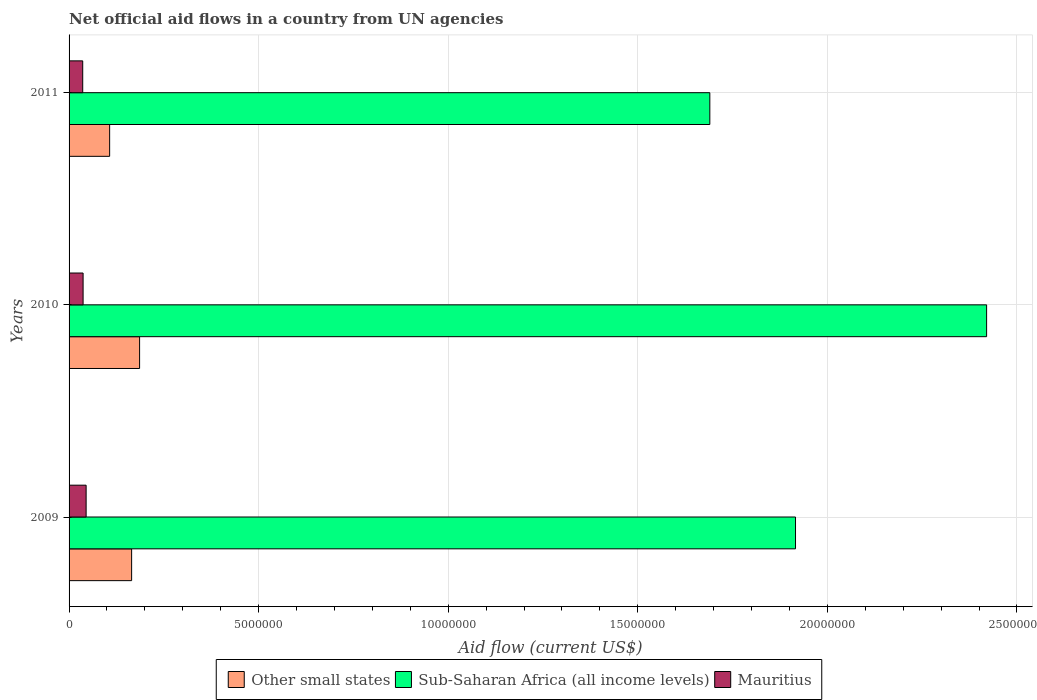How many different coloured bars are there?
Your response must be concise. 3. Are the number of bars on each tick of the Y-axis equal?
Keep it short and to the point. Yes. How many bars are there on the 3rd tick from the bottom?
Keep it short and to the point. 3. In how many cases, is the number of bars for a given year not equal to the number of legend labels?
Provide a short and direct response. 0. What is the net official aid flow in Other small states in 2009?
Provide a succinct answer. 1.65e+06. Across all years, what is the maximum net official aid flow in Mauritius?
Your answer should be very brief. 4.50e+05. Across all years, what is the minimum net official aid flow in Other small states?
Offer a terse response. 1.07e+06. In which year was the net official aid flow in Sub-Saharan Africa (all income levels) minimum?
Your answer should be compact. 2011. What is the total net official aid flow in Other small states in the graph?
Provide a short and direct response. 4.58e+06. What is the difference between the net official aid flow in Other small states in 2009 and that in 2011?
Make the answer very short. 5.80e+05. What is the difference between the net official aid flow in Sub-Saharan Africa (all income levels) in 2009 and the net official aid flow in Other small states in 2011?
Provide a short and direct response. 1.81e+07. What is the average net official aid flow in Mauritius per year?
Keep it short and to the point. 3.93e+05. In the year 2011, what is the difference between the net official aid flow in Sub-Saharan Africa (all income levels) and net official aid flow in Mauritius?
Your response must be concise. 1.65e+07. In how many years, is the net official aid flow in Sub-Saharan Africa (all income levels) greater than 13000000 US$?
Ensure brevity in your answer.  3. What is the ratio of the net official aid flow in Mauritius in 2010 to that in 2011?
Provide a succinct answer. 1.03. Is the net official aid flow in Other small states in 2009 less than that in 2010?
Offer a very short reply. Yes. What is the difference between the highest and the lowest net official aid flow in Sub-Saharan Africa (all income levels)?
Your response must be concise. 7.30e+06. In how many years, is the net official aid flow in Mauritius greater than the average net official aid flow in Mauritius taken over all years?
Offer a very short reply. 1. What does the 2nd bar from the top in 2011 represents?
Give a very brief answer. Sub-Saharan Africa (all income levels). What does the 1st bar from the bottom in 2010 represents?
Your answer should be compact. Other small states. Is it the case that in every year, the sum of the net official aid flow in Sub-Saharan Africa (all income levels) and net official aid flow in Other small states is greater than the net official aid flow in Mauritius?
Provide a short and direct response. Yes. Are all the bars in the graph horizontal?
Offer a very short reply. Yes. How many years are there in the graph?
Make the answer very short. 3. What is the difference between two consecutive major ticks on the X-axis?
Offer a very short reply. 5.00e+06. Does the graph contain any zero values?
Ensure brevity in your answer.  No. Does the graph contain grids?
Provide a succinct answer. Yes. Where does the legend appear in the graph?
Give a very brief answer. Bottom center. How many legend labels are there?
Your answer should be very brief. 3. What is the title of the graph?
Your answer should be compact. Net official aid flows in a country from UN agencies. Does "Other small states" appear as one of the legend labels in the graph?
Your answer should be very brief. Yes. What is the label or title of the X-axis?
Provide a succinct answer. Aid flow (current US$). What is the Aid flow (current US$) of Other small states in 2009?
Keep it short and to the point. 1.65e+06. What is the Aid flow (current US$) of Sub-Saharan Africa (all income levels) in 2009?
Provide a short and direct response. 1.92e+07. What is the Aid flow (current US$) in Other small states in 2010?
Provide a succinct answer. 1.86e+06. What is the Aid flow (current US$) of Sub-Saharan Africa (all income levels) in 2010?
Ensure brevity in your answer.  2.42e+07. What is the Aid flow (current US$) of Mauritius in 2010?
Your answer should be very brief. 3.70e+05. What is the Aid flow (current US$) of Other small states in 2011?
Offer a very short reply. 1.07e+06. What is the Aid flow (current US$) in Sub-Saharan Africa (all income levels) in 2011?
Ensure brevity in your answer.  1.69e+07. Across all years, what is the maximum Aid flow (current US$) of Other small states?
Give a very brief answer. 1.86e+06. Across all years, what is the maximum Aid flow (current US$) in Sub-Saharan Africa (all income levels)?
Keep it short and to the point. 2.42e+07. Across all years, what is the maximum Aid flow (current US$) of Mauritius?
Ensure brevity in your answer.  4.50e+05. Across all years, what is the minimum Aid flow (current US$) in Other small states?
Provide a short and direct response. 1.07e+06. Across all years, what is the minimum Aid flow (current US$) in Sub-Saharan Africa (all income levels)?
Ensure brevity in your answer.  1.69e+07. What is the total Aid flow (current US$) of Other small states in the graph?
Provide a short and direct response. 4.58e+06. What is the total Aid flow (current US$) of Sub-Saharan Africa (all income levels) in the graph?
Offer a terse response. 6.03e+07. What is the total Aid flow (current US$) of Mauritius in the graph?
Provide a succinct answer. 1.18e+06. What is the difference between the Aid flow (current US$) of Sub-Saharan Africa (all income levels) in 2009 and that in 2010?
Provide a short and direct response. -5.04e+06. What is the difference between the Aid flow (current US$) in Mauritius in 2009 and that in 2010?
Make the answer very short. 8.00e+04. What is the difference between the Aid flow (current US$) of Other small states in 2009 and that in 2011?
Your answer should be very brief. 5.80e+05. What is the difference between the Aid flow (current US$) of Sub-Saharan Africa (all income levels) in 2009 and that in 2011?
Give a very brief answer. 2.26e+06. What is the difference between the Aid flow (current US$) in Other small states in 2010 and that in 2011?
Provide a succinct answer. 7.90e+05. What is the difference between the Aid flow (current US$) in Sub-Saharan Africa (all income levels) in 2010 and that in 2011?
Ensure brevity in your answer.  7.30e+06. What is the difference between the Aid flow (current US$) of Other small states in 2009 and the Aid flow (current US$) of Sub-Saharan Africa (all income levels) in 2010?
Give a very brief answer. -2.26e+07. What is the difference between the Aid flow (current US$) of Other small states in 2009 and the Aid flow (current US$) of Mauritius in 2010?
Offer a terse response. 1.28e+06. What is the difference between the Aid flow (current US$) of Sub-Saharan Africa (all income levels) in 2009 and the Aid flow (current US$) of Mauritius in 2010?
Your answer should be compact. 1.88e+07. What is the difference between the Aid flow (current US$) in Other small states in 2009 and the Aid flow (current US$) in Sub-Saharan Africa (all income levels) in 2011?
Offer a very short reply. -1.52e+07. What is the difference between the Aid flow (current US$) of Other small states in 2009 and the Aid flow (current US$) of Mauritius in 2011?
Ensure brevity in your answer.  1.29e+06. What is the difference between the Aid flow (current US$) in Sub-Saharan Africa (all income levels) in 2009 and the Aid flow (current US$) in Mauritius in 2011?
Give a very brief answer. 1.88e+07. What is the difference between the Aid flow (current US$) of Other small states in 2010 and the Aid flow (current US$) of Sub-Saharan Africa (all income levels) in 2011?
Your response must be concise. -1.50e+07. What is the difference between the Aid flow (current US$) in Other small states in 2010 and the Aid flow (current US$) in Mauritius in 2011?
Offer a very short reply. 1.50e+06. What is the difference between the Aid flow (current US$) of Sub-Saharan Africa (all income levels) in 2010 and the Aid flow (current US$) of Mauritius in 2011?
Provide a succinct answer. 2.38e+07. What is the average Aid flow (current US$) of Other small states per year?
Offer a very short reply. 1.53e+06. What is the average Aid flow (current US$) in Sub-Saharan Africa (all income levels) per year?
Provide a succinct answer. 2.01e+07. What is the average Aid flow (current US$) in Mauritius per year?
Your response must be concise. 3.93e+05. In the year 2009, what is the difference between the Aid flow (current US$) of Other small states and Aid flow (current US$) of Sub-Saharan Africa (all income levels)?
Your answer should be compact. -1.75e+07. In the year 2009, what is the difference between the Aid flow (current US$) of Other small states and Aid flow (current US$) of Mauritius?
Your answer should be compact. 1.20e+06. In the year 2009, what is the difference between the Aid flow (current US$) in Sub-Saharan Africa (all income levels) and Aid flow (current US$) in Mauritius?
Offer a terse response. 1.87e+07. In the year 2010, what is the difference between the Aid flow (current US$) of Other small states and Aid flow (current US$) of Sub-Saharan Africa (all income levels)?
Offer a very short reply. -2.23e+07. In the year 2010, what is the difference between the Aid flow (current US$) of Other small states and Aid flow (current US$) of Mauritius?
Ensure brevity in your answer.  1.49e+06. In the year 2010, what is the difference between the Aid flow (current US$) in Sub-Saharan Africa (all income levels) and Aid flow (current US$) in Mauritius?
Keep it short and to the point. 2.38e+07. In the year 2011, what is the difference between the Aid flow (current US$) in Other small states and Aid flow (current US$) in Sub-Saharan Africa (all income levels)?
Your response must be concise. -1.58e+07. In the year 2011, what is the difference between the Aid flow (current US$) in Other small states and Aid flow (current US$) in Mauritius?
Your response must be concise. 7.10e+05. In the year 2011, what is the difference between the Aid flow (current US$) of Sub-Saharan Africa (all income levels) and Aid flow (current US$) of Mauritius?
Your response must be concise. 1.65e+07. What is the ratio of the Aid flow (current US$) of Other small states in 2009 to that in 2010?
Give a very brief answer. 0.89. What is the ratio of the Aid flow (current US$) in Sub-Saharan Africa (all income levels) in 2009 to that in 2010?
Keep it short and to the point. 0.79. What is the ratio of the Aid flow (current US$) in Mauritius in 2009 to that in 2010?
Make the answer very short. 1.22. What is the ratio of the Aid flow (current US$) of Other small states in 2009 to that in 2011?
Offer a terse response. 1.54. What is the ratio of the Aid flow (current US$) of Sub-Saharan Africa (all income levels) in 2009 to that in 2011?
Your answer should be compact. 1.13. What is the ratio of the Aid flow (current US$) of Mauritius in 2009 to that in 2011?
Your answer should be compact. 1.25. What is the ratio of the Aid flow (current US$) of Other small states in 2010 to that in 2011?
Make the answer very short. 1.74. What is the ratio of the Aid flow (current US$) of Sub-Saharan Africa (all income levels) in 2010 to that in 2011?
Your response must be concise. 1.43. What is the ratio of the Aid flow (current US$) in Mauritius in 2010 to that in 2011?
Ensure brevity in your answer.  1.03. What is the difference between the highest and the second highest Aid flow (current US$) of Sub-Saharan Africa (all income levels)?
Your answer should be compact. 5.04e+06. What is the difference between the highest and the lowest Aid flow (current US$) of Other small states?
Your answer should be compact. 7.90e+05. What is the difference between the highest and the lowest Aid flow (current US$) in Sub-Saharan Africa (all income levels)?
Keep it short and to the point. 7.30e+06. 